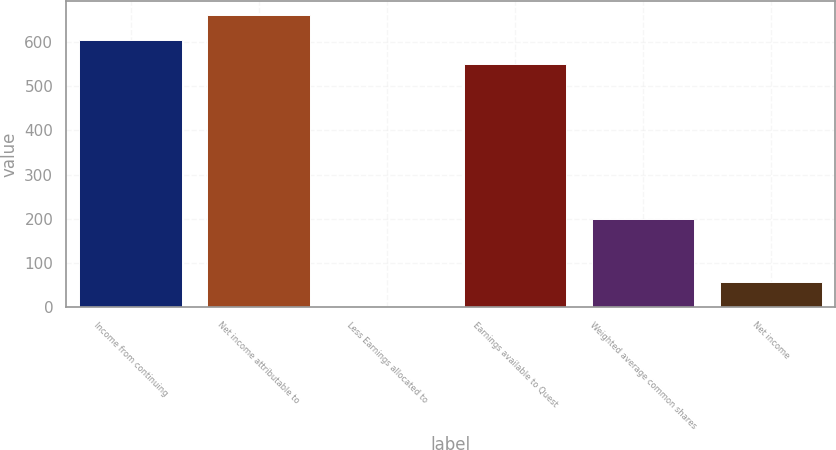Convert chart to OTSL. <chart><loc_0><loc_0><loc_500><loc_500><bar_chart><fcel>Income from continuing<fcel>Net income attributable to<fcel>Less Earnings allocated to<fcel>Earnings available to Quest<fcel>Weighted average common shares<fcel>Net income<nl><fcel>604.4<fcel>659.8<fcel>2<fcel>549<fcel>200.4<fcel>57.4<nl></chart> 